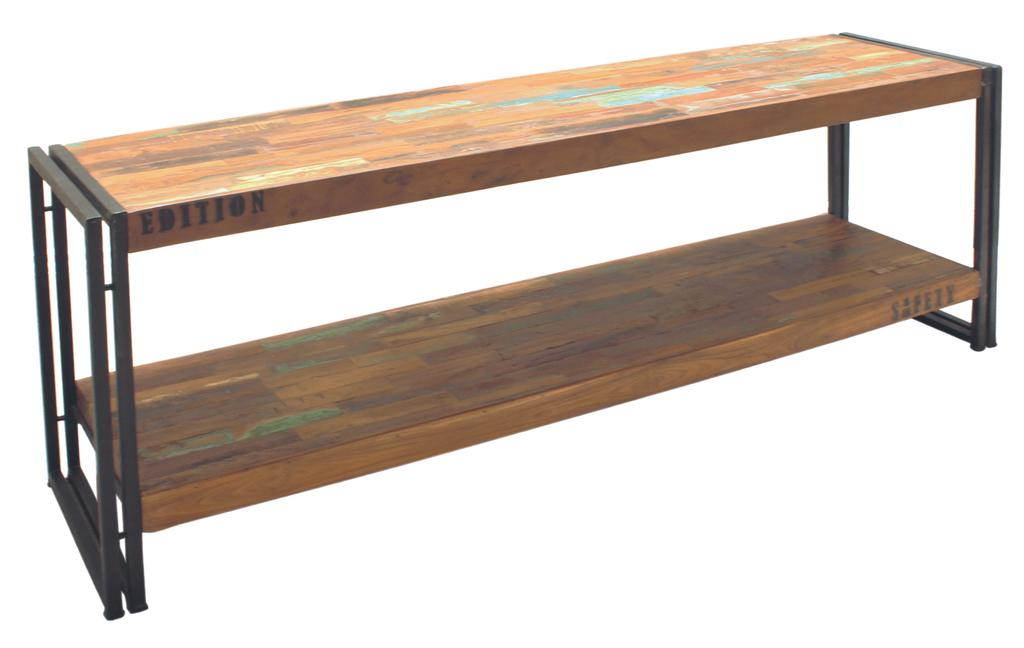<image>
Offer a succinct explanation of the picture presented. The wooden table has the word Edition written in black in it 